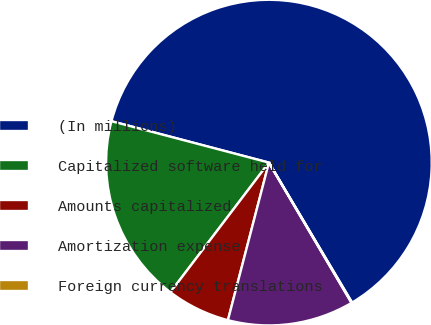<chart> <loc_0><loc_0><loc_500><loc_500><pie_chart><fcel>(In millions)<fcel>Capitalized software held for<fcel>Amounts capitalized<fcel>Amortization expense<fcel>Foreign currency translations<nl><fcel>62.37%<fcel>18.75%<fcel>6.29%<fcel>12.52%<fcel>0.06%<nl></chart> 